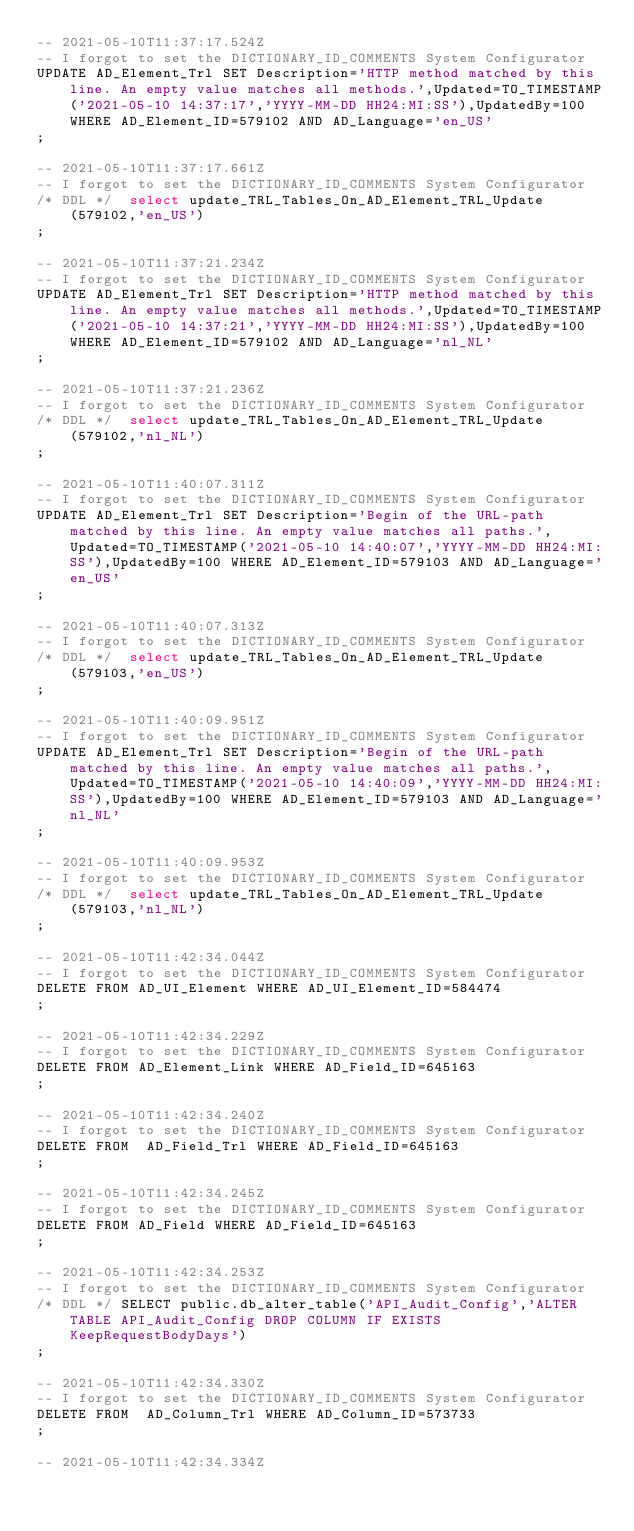Convert code to text. <code><loc_0><loc_0><loc_500><loc_500><_SQL_>-- 2021-05-10T11:37:17.524Z
-- I forgot to set the DICTIONARY_ID_COMMENTS System Configurator
UPDATE AD_Element_Trl SET Description='HTTP method matched by this line. An empty value matches all methods.',Updated=TO_TIMESTAMP('2021-05-10 14:37:17','YYYY-MM-DD HH24:MI:SS'),UpdatedBy=100 WHERE AD_Element_ID=579102 AND AD_Language='en_US'
;

-- 2021-05-10T11:37:17.661Z
-- I forgot to set the DICTIONARY_ID_COMMENTS System Configurator
/* DDL */  select update_TRL_Tables_On_AD_Element_TRL_Update(579102,'en_US') 
;

-- 2021-05-10T11:37:21.234Z
-- I forgot to set the DICTIONARY_ID_COMMENTS System Configurator
UPDATE AD_Element_Trl SET Description='HTTP method matched by this line. An empty value matches all methods.',Updated=TO_TIMESTAMP('2021-05-10 14:37:21','YYYY-MM-DD HH24:MI:SS'),UpdatedBy=100 WHERE AD_Element_ID=579102 AND AD_Language='nl_NL'
;

-- 2021-05-10T11:37:21.236Z
-- I forgot to set the DICTIONARY_ID_COMMENTS System Configurator
/* DDL */  select update_TRL_Tables_On_AD_Element_TRL_Update(579102,'nl_NL') 
;

-- 2021-05-10T11:40:07.311Z
-- I forgot to set the DICTIONARY_ID_COMMENTS System Configurator
UPDATE AD_Element_Trl SET Description='Begin of the URL-path matched by this line. An empty value matches all paths.',Updated=TO_TIMESTAMP('2021-05-10 14:40:07','YYYY-MM-DD HH24:MI:SS'),UpdatedBy=100 WHERE AD_Element_ID=579103 AND AD_Language='en_US'
;

-- 2021-05-10T11:40:07.313Z
-- I forgot to set the DICTIONARY_ID_COMMENTS System Configurator
/* DDL */  select update_TRL_Tables_On_AD_Element_TRL_Update(579103,'en_US') 
;

-- 2021-05-10T11:40:09.951Z
-- I forgot to set the DICTIONARY_ID_COMMENTS System Configurator
UPDATE AD_Element_Trl SET Description='Begin of the URL-path matched by this line. An empty value matches all paths.',Updated=TO_TIMESTAMP('2021-05-10 14:40:09','YYYY-MM-DD HH24:MI:SS'),UpdatedBy=100 WHERE AD_Element_ID=579103 AND AD_Language='nl_NL'
;

-- 2021-05-10T11:40:09.953Z
-- I forgot to set the DICTIONARY_ID_COMMENTS System Configurator
/* DDL */  select update_TRL_Tables_On_AD_Element_TRL_Update(579103,'nl_NL') 
;

-- 2021-05-10T11:42:34.044Z
-- I forgot to set the DICTIONARY_ID_COMMENTS System Configurator
DELETE FROM AD_UI_Element WHERE AD_UI_Element_ID=584474
;

-- 2021-05-10T11:42:34.229Z
-- I forgot to set the DICTIONARY_ID_COMMENTS System Configurator
DELETE FROM AD_Element_Link WHERE AD_Field_ID=645163
;

-- 2021-05-10T11:42:34.240Z
-- I forgot to set the DICTIONARY_ID_COMMENTS System Configurator
DELETE FROM  AD_Field_Trl WHERE AD_Field_ID=645163
;

-- 2021-05-10T11:42:34.245Z
-- I forgot to set the DICTIONARY_ID_COMMENTS System Configurator
DELETE FROM AD_Field WHERE AD_Field_ID=645163
;

-- 2021-05-10T11:42:34.253Z
-- I forgot to set the DICTIONARY_ID_COMMENTS System Configurator
/* DDL */ SELECT public.db_alter_table('API_Audit_Config','ALTER TABLE API_Audit_Config DROP COLUMN IF EXISTS KeepRequestBodyDays')
;

-- 2021-05-10T11:42:34.330Z
-- I forgot to set the DICTIONARY_ID_COMMENTS System Configurator
DELETE FROM  AD_Column_Trl WHERE AD_Column_ID=573733
;

-- 2021-05-10T11:42:34.334Z</code> 